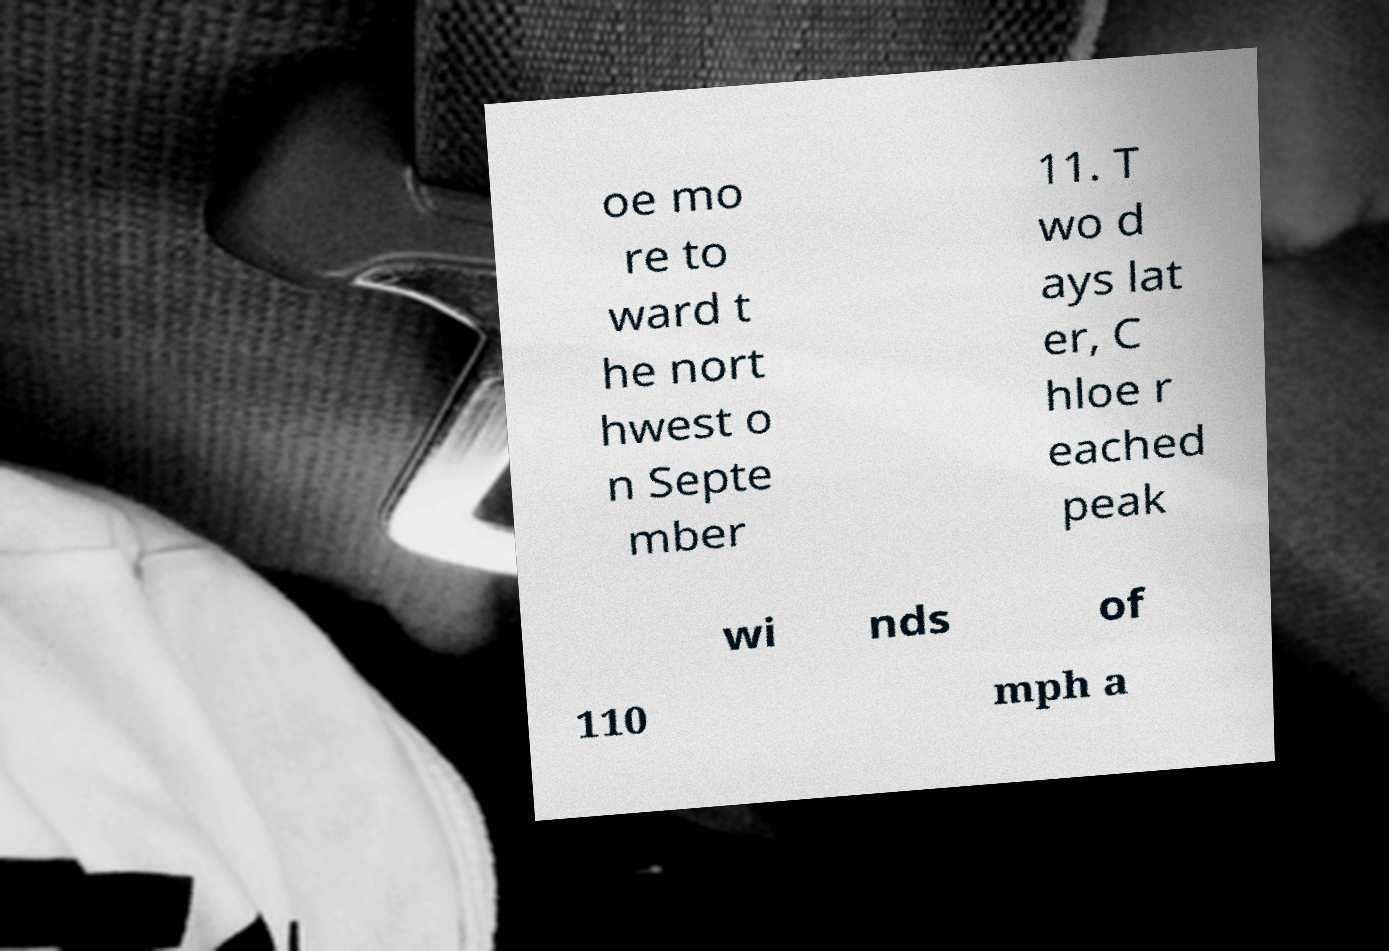Can you read and provide the text displayed in the image?This photo seems to have some interesting text. Can you extract and type it out for me? oe mo re to ward t he nort hwest o n Septe mber 11. T wo d ays lat er, C hloe r eached peak wi nds of 110 mph a 